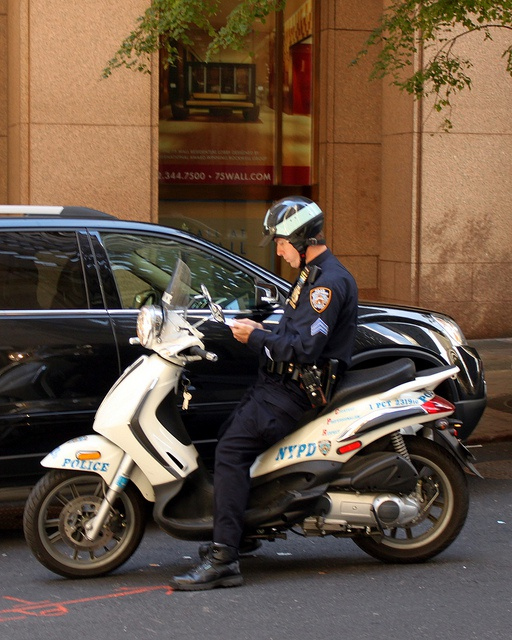Describe the objects in this image and their specific colors. I can see motorcycle in gray, black, ivory, and tan tones, car in gray, black, darkgreen, and white tones, and people in gray, black, and ivory tones in this image. 